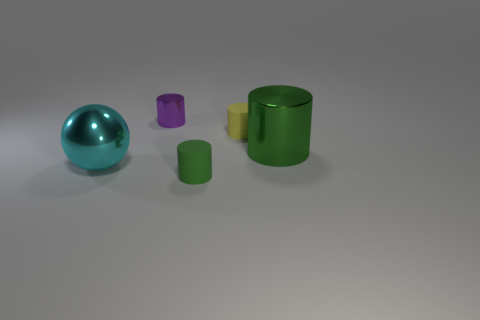What is the shape of the cyan shiny thing that is the same size as the green metal cylinder?
Ensure brevity in your answer.  Sphere. Is the size of the object that is to the left of the purple shiny object the same as the green cylinder that is on the left side of the big green thing?
Provide a succinct answer. No. There is another cylinder that is made of the same material as the big cylinder; what color is it?
Offer a very short reply. Purple. Is the tiny cylinder that is in front of the big green metal thing made of the same material as the small yellow cylinder that is to the right of the large cyan object?
Keep it short and to the point. Yes. Is there a green rubber cylinder of the same size as the yellow matte object?
Offer a terse response. Yes. What size is the green shiny cylinder that is in front of the rubber object that is behind the cyan ball?
Keep it short and to the point. Large. How many tiny cylinders are the same color as the large shiny ball?
Ensure brevity in your answer.  0. There is a big thing that is to the left of the large object that is on the right side of the purple object; what shape is it?
Provide a succinct answer. Sphere. What number of small red blocks have the same material as the cyan sphere?
Keep it short and to the point. 0. There is a small cylinder in front of the big green metal cylinder; what is it made of?
Keep it short and to the point. Rubber. 